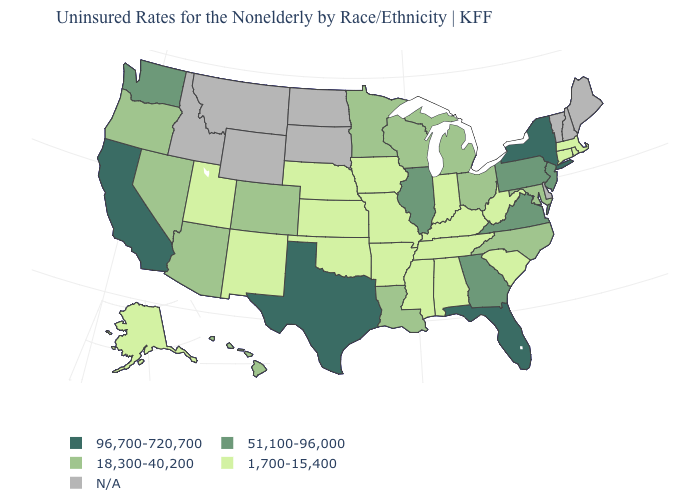Does Indiana have the lowest value in the USA?
Answer briefly. Yes. Which states have the highest value in the USA?
Concise answer only. California, Florida, New York, Texas. What is the highest value in the USA?
Short answer required. 96,700-720,700. Name the states that have a value in the range 18,300-40,200?
Short answer required. Arizona, Colorado, Hawaii, Louisiana, Maryland, Michigan, Minnesota, Nevada, North Carolina, Ohio, Oregon, Wisconsin. Does the map have missing data?
Short answer required. Yes. What is the value of Maine?
Short answer required. N/A. Name the states that have a value in the range N/A?
Answer briefly. Delaware, Idaho, Maine, Montana, New Hampshire, North Dakota, South Dakota, Vermont, Wyoming. What is the highest value in the South ?
Give a very brief answer. 96,700-720,700. Name the states that have a value in the range 96,700-720,700?
Quick response, please. California, Florida, New York, Texas. What is the value of Pennsylvania?
Write a very short answer. 51,100-96,000. Name the states that have a value in the range 1,700-15,400?
Answer briefly. Alabama, Alaska, Arkansas, Connecticut, Indiana, Iowa, Kansas, Kentucky, Massachusetts, Mississippi, Missouri, Nebraska, New Mexico, Oklahoma, Rhode Island, South Carolina, Tennessee, Utah, West Virginia. Does the map have missing data?
Be succinct. Yes. Among the states that border Indiana , which have the highest value?
Keep it brief. Illinois. Does the map have missing data?
Concise answer only. Yes. What is the value of North Carolina?
Be succinct. 18,300-40,200. 